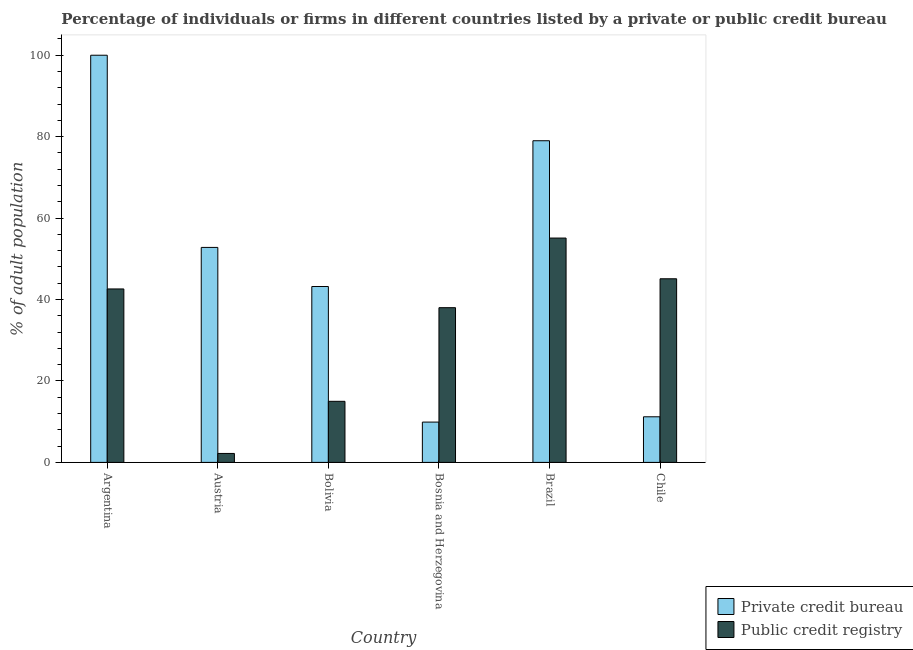Are the number of bars on each tick of the X-axis equal?
Provide a short and direct response. Yes. How many bars are there on the 1st tick from the left?
Make the answer very short. 2. In how many cases, is the number of bars for a given country not equal to the number of legend labels?
Offer a very short reply. 0. What is the percentage of firms listed by public credit bureau in Bosnia and Herzegovina?
Your response must be concise. 38. Across all countries, what is the maximum percentage of firms listed by private credit bureau?
Your answer should be very brief. 100. Across all countries, what is the minimum percentage of firms listed by private credit bureau?
Your answer should be compact. 9.9. What is the total percentage of firms listed by public credit bureau in the graph?
Offer a terse response. 198. What is the difference between the percentage of firms listed by public credit bureau in Austria and that in Bosnia and Herzegovina?
Offer a terse response. -35.8. What is the difference between the percentage of firms listed by private credit bureau in Chile and the percentage of firms listed by public credit bureau in Brazil?
Make the answer very short. -43.9. What is the average percentage of firms listed by private credit bureau per country?
Provide a short and direct response. 49.35. What is the difference between the percentage of firms listed by public credit bureau and percentage of firms listed by private credit bureau in Austria?
Keep it short and to the point. -50.6. What is the ratio of the percentage of firms listed by public credit bureau in Argentina to that in Austria?
Your answer should be very brief. 19.36. Is the difference between the percentage of firms listed by public credit bureau in Austria and Bosnia and Herzegovina greater than the difference between the percentage of firms listed by private credit bureau in Austria and Bosnia and Herzegovina?
Give a very brief answer. No. What is the difference between the highest and the second highest percentage of firms listed by private credit bureau?
Give a very brief answer. 21. What is the difference between the highest and the lowest percentage of firms listed by private credit bureau?
Your answer should be very brief. 90.1. Is the sum of the percentage of firms listed by private credit bureau in Bolivia and Bosnia and Herzegovina greater than the maximum percentage of firms listed by public credit bureau across all countries?
Provide a succinct answer. No. What does the 2nd bar from the left in Chile represents?
Make the answer very short. Public credit registry. What does the 2nd bar from the right in Argentina represents?
Give a very brief answer. Private credit bureau. Are all the bars in the graph horizontal?
Ensure brevity in your answer.  No. What is the difference between two consecutive major ticks on the Y-axis?
Your answer should be compact. 20. Are the values on the major ticks of Y-axis written in scientific E-notation?
Make the answer very short. No. Does the graph contain any zero values?
Your answer should be very brief. No. Does the graph contain grids?
Ensure brevity in your answer.  No. Where does the legend appear in the graph?
Your answer should be compact. Bottom right. How many legend labels are there?
Make the answer very short. 2. What is the title of the graph?
Your answer should be compact. Percentage of individuals or firms in different countries listed by a private or public credit bureau. What is the label or title of the X-axis?
Your answer should be very brief. Country. What is the label or title of the Y-axis?
Provide a short and direct response. % of adult population. What is the % of adult population of Private credit bureau in Argentina?
Ensure brevity in your answer.  100. What is the % of adult population of Public credit registry in Argentina?
Your answer should be compact. 42.6. What is the % of adult population in Private credit bureau in Austria?
Ensure brevity in your answer.  52.8. What is the % of adult population of Private credit bureau in Bolivia?
Your answer should be compact. 43.2. What is the % of adult population in Private credit bureau in Bosnia and Herzegovina?
Offer a very short reply. 9.9. What is the % of adult population in Public credit registry in Bosnia and Herzegovina?
Keep it short and to the point. 38. What is the % of adult population in Private credit bureau in Brazil?
Provide a succinct answer. 79. What is the % of adult population of Public credit registry in Brazil?
Give a very brief answer. 55.1. What is the % of adult population of Private credit bureau in Chile?
Ensure brevity in your answer.  11.2. What is the % of adult population in Public credit registry in Chile?
Your answer should be very brief. 45.1. Across all countries, what is the maximum % of adult population of Public credit registry?
Provide a short and direct response. 55.1. Across all countries, what is the minimum % of adult population of Private credit bureau?
Your answer should be very brief. 9.9. Across all countries, what is the minimum % of adult population in Public credit registry?
Make the answer very short. 2.2. What is the total % of adult population of Private credit bureau in the graph?
Your answer should be very brief. 296.1. What is the total % of adult population in Public credit registry in the graph?
Offer a terse response. 198. What is the difference between the % of adult population of Private credit bureau in Argentina and that in Austria?
Offer a very short reply. 47.2. What is the difference between the % of adult population of Public credit registry in Argentina and that in Austria?
Make the answer very short. 40.4. What is the difference between the % of adult population in Private credit bureau in Argentina and that in Bolivia?
Give a very brief answer. 56.8. What is the difference between the % of adult population in Public credit registry in Argentina and that in Bolivia?
Make the answer very short. 27.6. What is the difference between the % of adult population in Private credit bureau in Argentina and that in Bosnia and Herzegovina?
Give a very brief answer. 90.1. What is the difference between the % of adult population of Public credit registry in Argentina and that in Bosnia and Herzegovina?
Your response must be concise. 4.6. What is the difference between the % of adult population in Public credit registry in Argentina and that in Brazil?
Your answer should be very brief. -12.5. What is the difference between the % of adult population in Private credit bureau in Argentina and that in Chile?
Your answer should be very brief. 88.8. What is the difference between the % of adult population in Public credit registry in Austria and that in Bolivia?
Offer a terse response. -12.8. What is the difference between the % of adult population in Private credit bureau in Austria and that in Bosnia and Herzegovina?
Offer a terse response. 42.9. What is the difference between the % of adult population of Public credit registry in Austria and that in Bosnia and Herzegovina?
Your response must be concise. -35.8. What is the difference between the % of adult population in Private credit bureau in Austria and that in Brazil?
Give a very brief answer. -26.2. What is the difference between the % of adult population in Public credit registry in Austria and that in Brazil?
Your answer should be very brief. -52.9. What is the difference between the % of adult population in Private credit bureau in Austria and that in Chile?
Your response must be concise. 41.6. What is the difference between the % of adult population in Public credit registry in Austria and that in Chile?
Provide a short and direct response. -42.9. What is the difference between the % of adult population of Private credit bureau in Bolivia and that in Bosnia and Herzegovina?
Offer a terse response. 33.3. What is the difference between the % of adult population of Public credit registry in Bolivia and that in Bosnia and Herzegovina?
Your answer should be very brief. -23. What is the difference between the % of adult population of Private credit bureau in Bolivia and that in Brazil?
Your answer should be very brief. -35.8. What is the difference between the % of adult population of Public credit registry in Bolivia and that in Brazil?
Provide a short and direct response. -40.1. What is the difference between the % of adult population of Private credit bureau in Bolivia and that in Chile?
Your response must be concise. 32. What is the difference between the % of adult population of Public credit registry in Bolivia and that in Chile?
Provide a succinct answer. -30.1. What is the difference between the % of adult population of Private credit bureau in Bosnia and Herzegovina and that in Brazil?
Keep it short and to the point. -69.1. What is the difference between the % of adult population in Public credit registry in Bosnia and Herzegovina and that in Brazil?
Make the answer very short. -17.1. What is the difference between the % of adult population in Private credit bureau in Brazil and that in Chile?
Give a very brief answer. 67.8. What is the difference between the % of adult population of Public credit registry in Brazil and that in Chile?
Your response must be concise. 10. What is the difference between the % of adult population of Private credit bureau in Argentina and the % of adult population of Public credit registry in Austria?
Your answer should be very brief. 97.8. What is the difference between the % of adult population in Private credit bureau in Argentina and the % of adult population in Public credit registry in Brazil?
Offer a very short reply. 44.9. What is the difference between the % of adult population of Private credit bureau in Argentina and the % of adult population of Public credit registry in Chile?
Offer a terse response. 54.9. What is the difference between the % of adult population in Private credit bureau in Austria and the % of adult population in Public credit registry in Bolivia?
Provide a short and direct response. 37.8. What is the difference between the % of adult population of Private credit bureau in Austria and the % of adult population of Public credit registry in Bosnia and Herzegovina?
Give a very brief answer. 14.8. What is the difference between the % of adult population of Private credit bureau in Austria and the % of adult population of Public credit registry in Brazil?
Your answer should be compact. -2.3. What is the difference between the % of adult population in Private credit bureau in Bolivia and the % of adult population in Public credit registry in Bosnia and Herzegovina?
Keep it short and to the point. 5.2. What is the difference between the % of adult population of Private credit bureau in Bolivia and the % of adult population of Public credit registry in Chile?
Ensure brevity in your answer.  -1.9. What is the difference between the % of adult population of Private credit bureau in Bosnia and Herzegovina and the % of adult population of Public credit registry in Brazil?
Provide a succinct answer. -45.2. What is the difference between the % of adult population of Private credit bureau in Bosnia and Herzegovina and the % of adult population of Public credit registry in Chile?
Your answer should be compact. -35.2. What is the difference between the % of adult population of Private credit bureau in Brazil and the % of adult population of Public credit registry in Chile?
Your response must be concise. 33.9. What is the average % of adult population of Private credit bureau per country?
Make the answer very short. 49.35. What is the difference between the % of adult population in Private credit bureau and % of adult population in Public credit registry in Argentina?
Keep it short and to the point. 57.4. What is the difference between the % of adult population of Private credit bureau and % of adult population of Public credit registry in Austria?
Ensure brevity in your answer.  50.6. What is the difference between the % of adult population in Private credit bureau and % of adult population in Public credit registry in Bolivia?
Ensure brevity in your answer.  28.2. What is the difference between the % of adult population of Private credit bureau and % of adult population of Public credit registry in Bosnia and Herzegovina?
Ensure brevity in your answer.  -28.1. What is the difference between the % of adult population in Private credit bureau and % of adult population in Public credit registry in Brazil?
Your response must be concise. 23.9. What is the difference between the % of adult population in Private credit bureau and % of adult population in Public credit registry in Chile?
Your response must be concise. -33.9. What is the ratio of the % of adult population in Private credit bureau in Argentina to that in Austria?
Make the answer very short. 1.89. What is the ratio of the % of adult population of Public credit registry in Argentina to that in Austria?
Provide a succinct answer. 19.36. What is the ratio of the % of adult population of Private credit bureau in Argentina to that in Bolivia?
Provide a succinct answer. 2.31. What is the ratio of the % of adult population of Public credit registry in Argentina to that in Bolivia?
Offer a very short reply. 2.84. What is the ratio of the % of adult population in Private credit bureau in Argentina to that in Bosnia and Herzegovina?
Offer a terse response. 10.1. What is the ratio of the % of adult population in Public credit registry in Argentina to that in Bosnia and Herzegovina?
Your response must be concise. 1.12. What is the ratio of the % of adult population of Private credit bureau in Argentina to that in Brazil?
Your answer should be very brief. 1.27. What is the ratio of the % of adult population in Public credit registry in Argentina to that in Brazil?
Your answer should be compact. 0.77. What is the ratio of the % of adult population of Private credit bureau in Argentina to that in Chile?
Your answer should be compact. 8.93. What is the ratio of the % of adult population of Public credit registry in Argentina to that in Chile?
Make the answer very short. 0.94. What is the ratio of the % of adult population of Private credit bureau in Austria to that in Bolivia?
Give a very brief answer. 1.22. What is the ratio of the % of adult population of Public credit registry in Austria to that in Bolivia?
Your response must be concise. 0.15. What is the ratio of the % of adult population of Private credit bureau in Austria to that in Bosnia and Herzegovina?
Offer a very short reply. 5.33. What is the ratio of the % of adult population in Public credit registry in Austria to that in Bosnia and Herzegovina?
Your response must be concise. 0.06. What is the ratio of the % of adult population of Private credit bureau in Austria to that in Brazil?
Make the answer very short. 0.67. What is the ratio of the % of adult population in Public credit registry in Austria to that in Brazil?
Ensure brevity in your answer.  0.04. What is the ratio of the % of adult population in Private credit bureau in Austria to that in Chile?
Offer a terse response. 4.71. What is the ratio of the % of adult population of Public credit registry in Austria to that in Chile?
Your answer should be compact. 0.05. What is the ratio of the % of adult population of Private credit bureau in Bolivia to that in Bosnia and Herzegovina?
Give a very brief answer. 4.36. What is the ratio of the % of adult population of Public credit registry in Bolivia to that in Bosnia and Herzegovina?
Keep it short and to the point. 0.39. What is the ratio of the % of adult population of Private credit bureau in Bolivia to that in Brazil?
Give a very brief answer. 0.55. What is the ratio of the % of adult population of Public credit registry in Bolivia to that in Brazil?
Provide a succinct answer. 0.27. What is the ratio of the % of adult population in Private credit bureau in Bolivia to that in Chile?
Your answer should be compact. 3.86. What is the ratio of the % of adult population of Public credit registry in Bolivia to that in Chile?
Your answer should be compact. 0.33. What is the ratio of the % of adult population in Private credit bureau in Bosnia and Herzegovina to that in Brazil?
Provide a short and direct response. 0.13. What is the ratio of the % of adult population in Public credit registry in Bosnia and Herzegovina to that in Brazil?
Your answer should be very brief. 0.69. What is the ratio of the % of adult population in Private credit bureau in Bosnia and Herzegovina to that in Chile?
Make the answer very short. 0.88. What is the ratio of the % of adult population of Public credit registry in Bosnia and Herzegovina to that in Chile?
Your answer should be compact. 0.84. What is the ratio of the % of adult population of Private credit bureau in Brazil to that in Chile?
Provide a short and direct response. 7.05. What is the ratio of the % of adult population of Public credit registry in Brazil to that in Chile?
Provide a succinct answer. 1.22. What is the difference between the highest and the second highest % of adult population of Private credit bureau?
Make the answer very short. 21. What is the difference between the highest and the second highest % of adult population in Public credit registry?
Keep it short and to the point. 10. What is the difference between the highest and the lowest % of adult population in Private credit bureau?
Your response must be concise. 90.1. What is the difference between the highest and the lowest % of adult population of Public credit registry?
Offer a terse response. 52.9. 